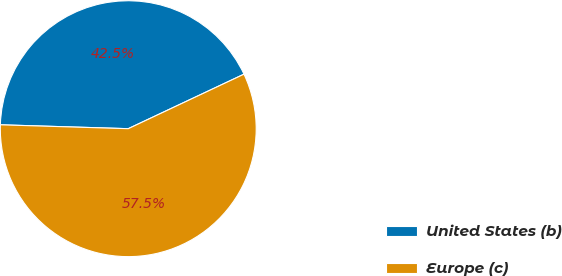Convert chart. <chart><loc_0><loc_0><loc_500><loc_500><pie_chart><fcel>United States (b)<fcel>Europe (c)<nl><fcel>42.51%<fcel>57.49%<nl></chart> 